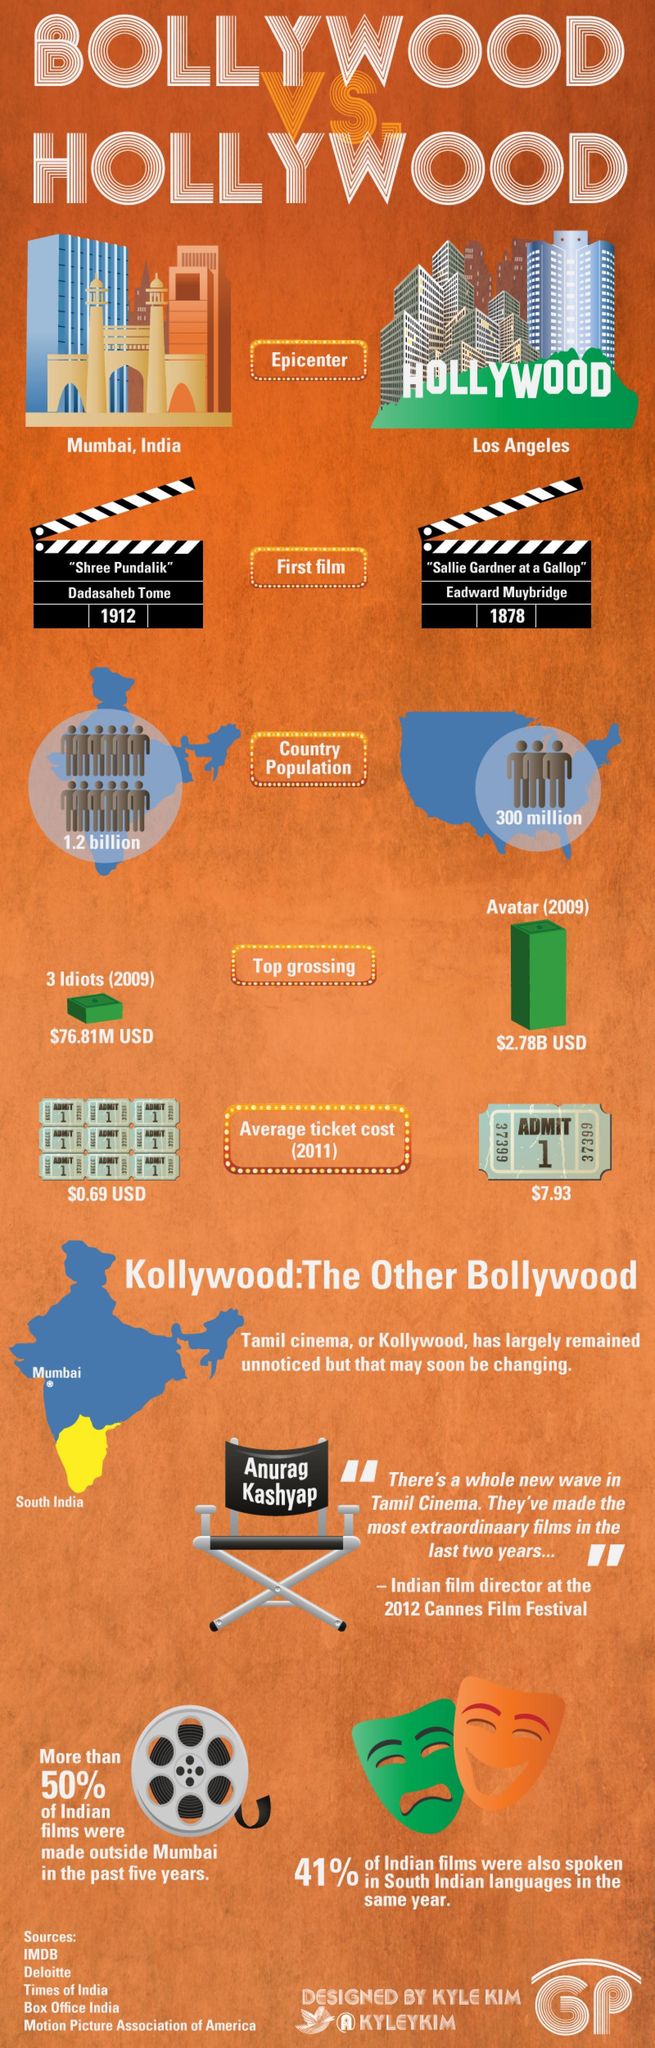Which place is known as the Epicenter of Hollywood?
Answer the question with a short phrase. Los Angeles In which year first movie of Hollywood was released? 1878 Which part of India is coloured in Yellow in the map? South India How much money did the movie Avatar earned? $2.78B USD What is the name of the first Indian movie? Shree Pundalik What is the average ticket cost of a Hollywood movie in 2011? $7.93 Which was the top grossing movie of Hollywood? Avatar What percentage of Indian films were not spoken in south Indian languages in 2012? 59 What is the name of the actor in the movie "Sallie Gardner at a Gallop"? Eadward Muybridge What is the population of India? 1.2 billion 